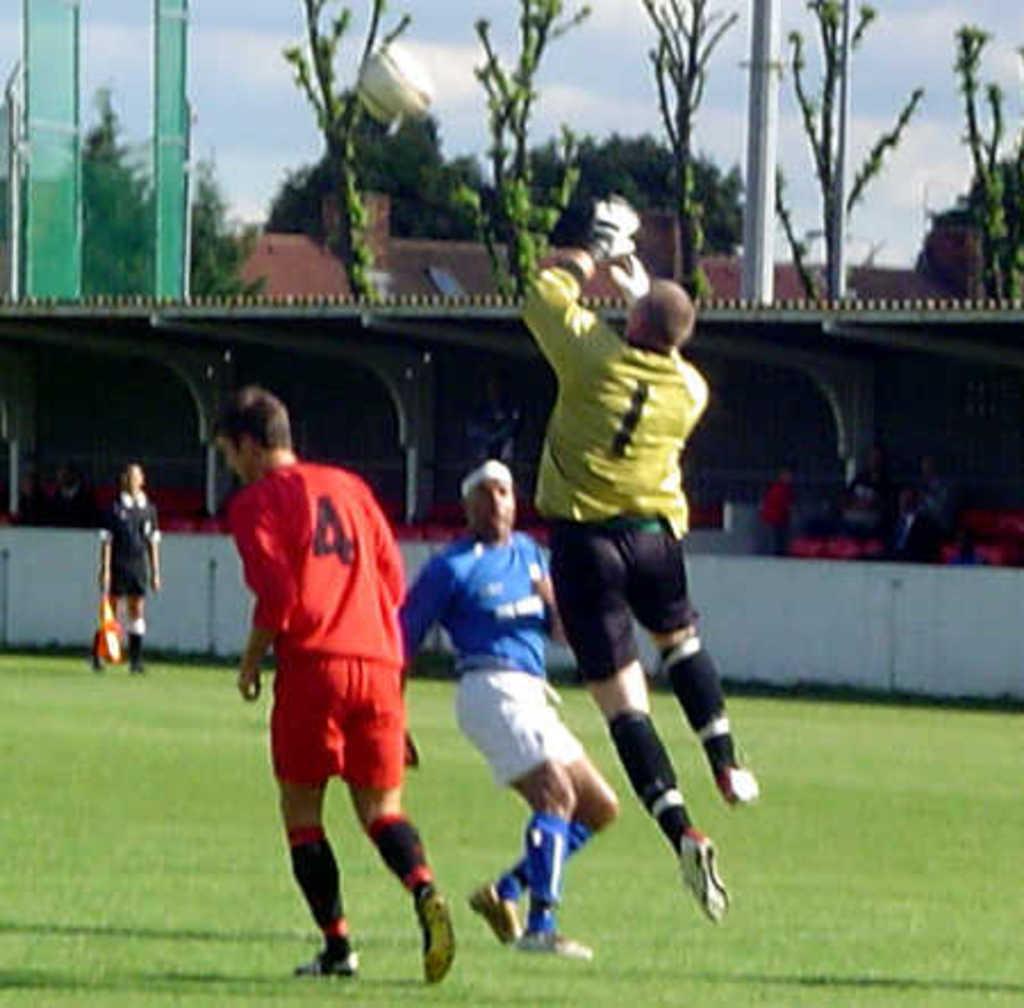What number is the goalie?
Your answer should be very brief. 1. What is the number of the guy in red?
Your response must be concise. 4. 